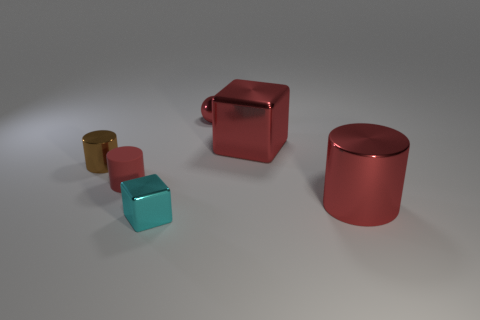Add 4 cyan cubes. How many objects exist? 10 Subtract all spheres. How many objects are left? 5 Subtract 0 purple balls. How many objects are left? 6 Subtract all tiny red metal spheres. Subtract all tiny things. How many objects are left? 1 Add 3 red metallic objects. How many red metallic objects are left? 6 Add 1 small metallic balls. How many small metallic balls exist? 2 